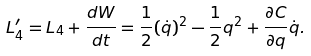<formula> <loc_0><loc_0><loc_500><loc_500>L ^ { \prime } _ { 4 } = L _ { 4 } + \frac { d W } { d t } = \frac { 1 } { 2 } ( \dot { q } ) ^ { 2 } - \frac { 1 } { 2 } q ^ { 2 } + \frac { \partial C } { \partial q } \dot { q } .</formula> 